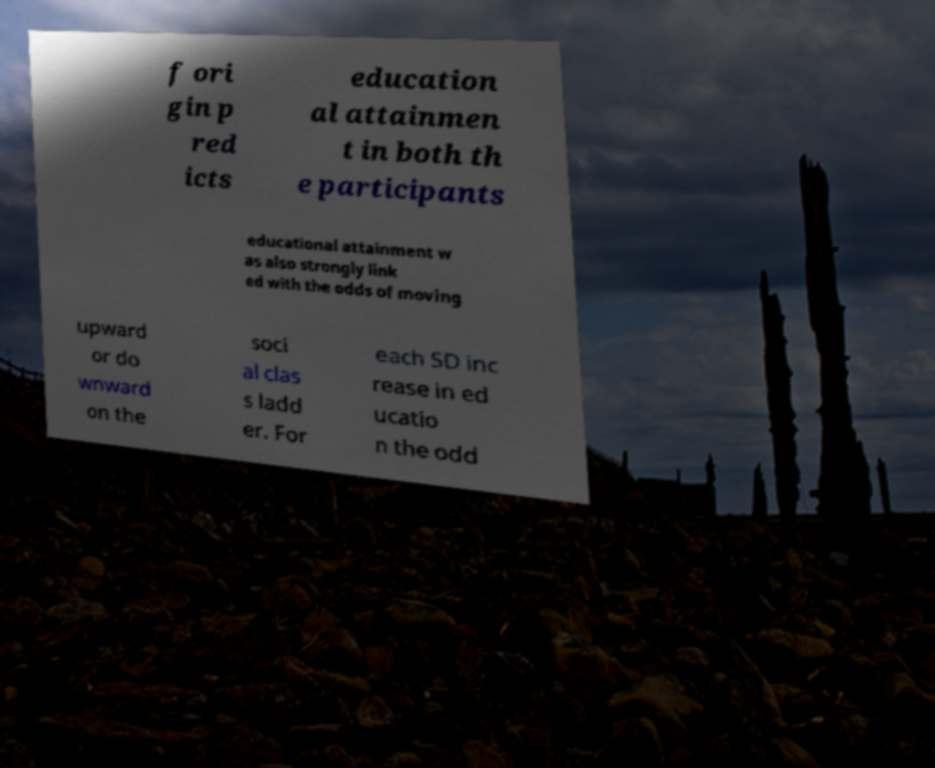Could you assist in decoding the text presented in this image and type it out clearly? f ori gin p red icts education al attainmen t in both th e participants educational attainment w as also strongly link ed with the odds of moving upward or do wnward on the soci al clas s ladd er. For each SD inc rease in ed ucatio n the odd 